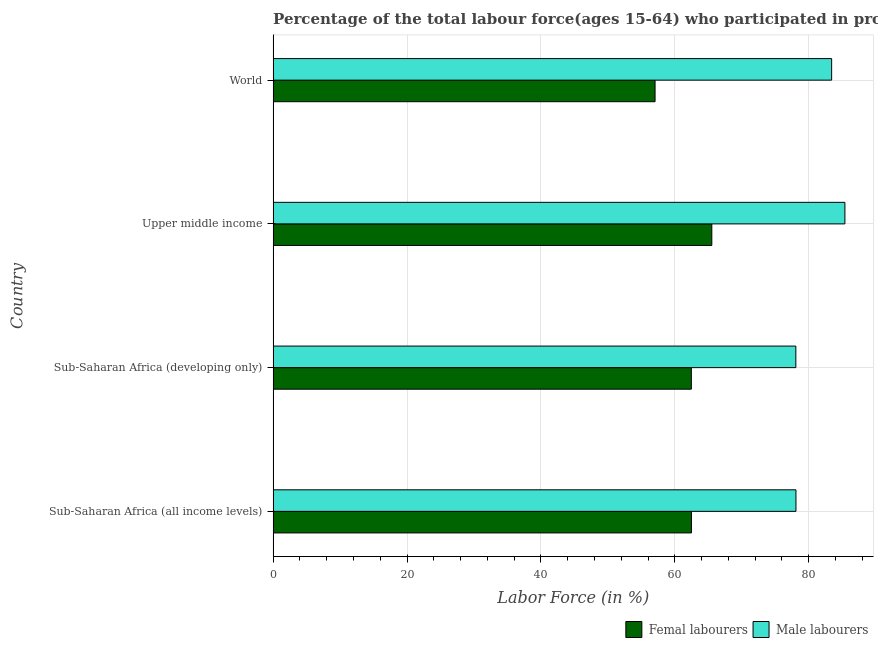How many different coloured bars are there?
Your response must be concise. 2. How many groups of bars are there?
Provide a succinct answer. 4. Are the number of bars on each tick of the Y-axis equal?
Your response must be concise. Yes. How many bars are there on the 4th tick from the top?
Your response must be concise. 2. How many bars are there on the 2nd tick from the bottom?
Provide a short and direct response. 2. What is the label of the 1st group of bars from the top?
Your answer should be compact. World. What is the percentage of male labour force in World?
Give a very brief answer. 83.43. Across all countries, what is the maximum percentage of male labour force?
Your answer should be compact. 85.41. Across all countries, what is the minimum percentage of female labor force?
Your answer should be compact. 57.05. In which country was the percentage of male labour force maximum?
Your answer should be compact. Upper middle income. In which country was the percentage of male labour force minimum?
Ensure brevity in your answer.  Sub-Saharan Africa (developing only). What is the total percentage of male labour force in the graph?
Offer a terse response. 325.01. What is the difference between the percentage of female labor force in Sub-Saharan Africa (developing only) and that in World?
Give a very brief answer. 5.42. What is the difference between the percentage of male labour force in World and the percentage of female labor force in Sub-Saharan Africa (all income levels)?
Give a very brief answer. 20.94. What is the average percentage of male labour force per country?
Your answer should be very brief. 81.25. What is the difference between the percentage of female labor force and percentage of male labour force in World?
Your response must be concise. -26.37. In how many countries, is the percentage of male labour force greater than 12 %?
Provide a succinct answer. 4. What is the ratio of the percentage of male labour force in Sub-Saharan Africa (all income levels) to that in World?
Offer a very short reply. 0.94. Is the percentage of female labor force in Sub-Saharan Africa (developing only) less than that in World?
Offer a terse response. No. Is the difference between the percentage of female labor force in Sub-Saharan Africa (developing only) and Upper middle income greater than the difference between the percentage of male labour force in Sub-Saharan Africa (developing only) and Upper middle income?
Keep it short and to the point. Yes. What is the difference between the highest and the second highest percentage of male labour force?
Your response must be concise. 1.98. What is the difference between the highest and the lowest percentage of female labor force?
Your response must be concise. 8.48. In how many countries, is the percentage of male labour force greater than the average percentage of male labour force taken over all countries?
Offer a very short reply. 2. What does the 2nd bar from the top in Sub-Saharan Africa (all income levels) represents?
Make the answer very short. Femal labourers. What does the 2nd bar from the bottom in World represents?
Your answer should be very brief. Male labourers. Are all the bars in the graph horizontal?
Your answer should be compact. Yes. Are the values on the major ticks of X-axis written in scientific E-notation?
Ensure brevity in your answer.  No. How many legend labels are there?
Provide a succinct answer. 2. What is the title of the graph?
Provide a short and direct response. Percentage of the total labour force(ages 15-64) who participated in production in 1999. Does "Personal remittances" appear as one of the legend labels in the graph?
Your answer should be very brief. No. What is the label or title of the X-axis?
Your response must be concise. Labor Force (in %). What is the Labor Force (in %) of Femal labourers in Sub-Saharan Africa (all income levels)?
Provide a short and direct response. 62.49. What is the Labor Force (in %) of Male labourers in Sub-Saharan Africa (all income levels)?
Offer a very short reply. 78.1. What is the Labor Force (in %) of Femal labourers in Sub-Saharan Africa (developing only)?
Ensure brevity in your answer.  62.47. What is the Labor Force (in %) in Male labourers in Sub-Saharan Africa (developing only)?
Make the answer very short. 78.08. What is the Labor Force (in %) of Femal labourers in Upper middle income?
Your answer should be compact. 65.53. What is the Labor Force (in %) of Male labourers in Upper middle income?
Offer a very short reply. 85.41. What is the Labor Force (in %) of Femal labourers in World?
Offer a terse response. 57.05. What is the Labor Force (in %) of Male labourers in World?
Ensure brevity in your answer.  83.43. Across all countries, what is the maximum Labor Force (in %) in Femal labourers?
Give a very brief answer. 65.53. Across all countries, what is the maximum Labor Force (in %) of Male labourers?
Provide a short and direct response. 85.41. Across all countries, what is the minimum Labor Force (in %) in Femal labourers?
Provide a short and direct response. 57.05. Across all countries, what is the minimum Labor Force (in %) of Male labourers?
Your response must be concise. 78.08. What is the total Labor Force (in %) of Femal labourers in the graph?
Make the answer very short. 247.54. What is the total Labor Force (in %) in Male labourers in the graph?
Provide a succinct answer. 325.01. What is the difference between the Labor Force (in %) of Femal labourers in Sub-Saharan Africa (all income levels) and that in Sub-Saharan Africa (developing only)?
Give a very brief answer. 0.02. What is the difference between the Labor Force (in %) in Male labourers in Sub-Saharan Africa (all income levels) and that in Sub-Saharan Africa (developing only)?
Provide a succinct answer. 0.01. What is the difference between the Labor Force (in %) in Femal labourers in Sub-Saharan Africa (all income levels) and that in Upper middle income?
Keep it short and to the point. -3.04. What is the difference between the Labor Force (in %) in Male labourers in Sub-Saharan Africa (all income levels) and that in Upper middle income?
Your answer should be very brief. -7.31. What is the difference between the Labor Force (in %) in Femal labourers in Sub-Saharan Africa (all income levels) and that in World?
Make the answer very short. 5.43. What is the difference between the Labor Force (in %) of Male labourers in Sub-Saharan Africa (all income levels) and that in World?
Offer a very short reply. -5.33. What is the difference between the Labor Force (in %) of Femal labourers in Sub-Saharan Africa (developing only) and that in Upper middle income?
Your answer should be very brief. -3.06. What is the difference between the Labor Force (in %) in Male labourers in Sub-Saharan Africa (developing only) and that in Upper middle income?
Offer a very short reply. -7.33. What is the difference between the Labor Force (in %) of Femal labourers in Sub-Saharan Africa (developing only) and that in World?
Give a very brief answer. 5.42. What is the difference between the Labor Force (in %) of Male labourers in Sub-Saharan Africa (developing only) and that in World?
Keep it short and to the point. -5.34. What is the difference between the Labor Force (in %) in Femal labourers in Upper middle income and that in World?
Provide a short and direct response. 8.48. What is the difference between the Labor Force (in %) in Male labourers in Upper middle income and that in World?
Your answer should be compact. 1.98. What is the difference between the Labor Force (in %) of Femal labourers in Sub-Saharan Africa (all income levels) and the Labor Force (in %) of Male labourers in Sub-Saharan Africa (developing only)?
Provide a succinct answer. -15.6. What is the difference between the Labor Force (in %) in Femal labourers in Sub-Saharan Africa (all income levels) and the Labor Force (in %) in Male labourers in Upper middle income?
Offer a terse response. -22.92. What is the difference between the Labor Force (in %) in Femal labourers in Sub-Saharan Africa (all income levels) and the Labor Force (in %) in Male labourers in World?
Offer a very short reply. -20.94. What is the difference between the Labor Force (in %) in Femal labourers in Sub-Saharan Africa (developing only) and the Labor Force (in %) in Male labourers in Upper middle income?
Ensure brevity in your answer.  -22.94. What is the difference between the Labor Force (in %) in Femal labourers in Sub-Saharan Africa (developing only) and the Labor Force (in %) in Male labourers in World?
Your response must be concise. -20.96. What is the difference between the Labor Force (in %) in Femal labourers in Upper middle income and the Labor Force (in %) in Male labourers in World?
Keep it short and to the point. -17.9. What is the average Labor Force (in %) of Femal labourers per country?
Make the answer very short. 61.88. What is the average Labor Force (in %) in Male labourers per country?
Ensure brevity in your answer.  81.25. What is the difference between the Labor Force (in %) in Femal labourers and Labor Force (in %) in Male labourers in Sub-Saharan Africa (all income levels)?
Your answer should be very brief. -15.61. What is the difference between the Labor Force (in %) of Femal labourers and Labor Force (in %) of Male labourers in Sub-Saharan Africa (developing only)?
Ensure brevity in your answer.  -15.61. What is the difference between the Labor Force (in %) of Femal labourers and Labor Force (in %) of Male labourers in Upper middle income?
Make the answer very short. -19.88. What is the difference between the Labor Force (in %) in Femal labourers and Labor Force (in %) in Male labourers in World?
Give a very brief answer. -26.37. What is the ratio of the Labor Force (in %) in Femal labourers in Sub-Saharan Africa (all income levels) to that in Upper middle income?
Your response must be concise. 0.95. What is the ratio of the Labor Force (in %) of Male labourers in Sub-Saharan Africa (all income levels) to that in Upper middle income?
Ensure brevity in your answer.  0.91. What is the ratio of the Labor Force (in %) in Femal labourers in Sub-Saharan Africa (all income levels) to that in World?
Provide a succinct answer. 1.1. What is the ratio of the Labor Force (in %) in Male labourers in Sub-Saharan Africa (all income levels) to that in World?
Ensure brevity in your answer.  0.94. What is the ratio of the Labor Force (in %) in Femal labourers in Sub-Saharan Africa (developing only) to that in Upper middle income?
Give a very brief answer. 0.95. What is the ratio of the Labor Force (in %) of Male labourers in Sub-Saharan Africa (developing only) to that in Upper middle income?
Keep it short and to the point. 0.91. What is the ratio of the Labor Force (in %) in Femal labourers in Sub-Saharan Africa (developing only) to that in World?
Give a very brief answer. 1.09. What is the ratio of the Labor Force (in %) in Male labourers in Sub-Saharan Africa (developing only) to that in World?
Provide a succinct answer. 0.94. What is the ratio of the Labor Force (in %) of Femal labourers in Upper middle income to that in World?
Your response must be concise. 1.15. What is the ratio of the Labor Force (in %) of Male labourers in Upper middle income to that in World?
Keep it short and to the point. 1.02. What is the difference between the highest and the second highest Labor Force (in %) of Femal labourers?
Your answer should be very brief. 3.04. What is the difference between the highest and the second highest Labor Force (in %) in Male labourers?
Your answer should be compact. 1.98. What is the difference between the highest and the lowest Labor Force (in %) in Femal labourers?
Your response must be concise. 8.48. What is the difference between the highest and the lowest Labor Force (in %) in Male labourers?
Make the answer very short. 7.33. 